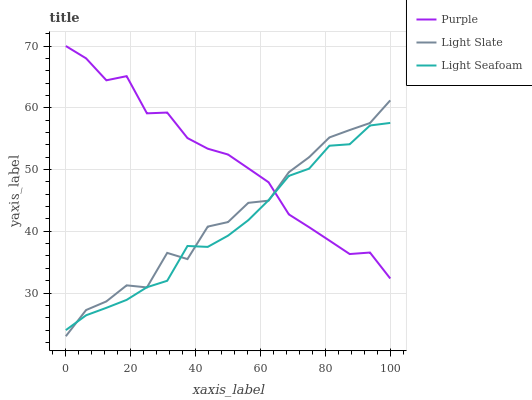Does Light Seafoam have the minimum area under the curve?
Answer yes or no. Yes. Does Purple have the maximum area under the curve?
Answer yes or no. Yes. Does Light Slate have the minimum area under the curve?
Answer yes or no. No. Does Light Slate have the maximum area under the curve?
Answer yes or no. No. Is Light Seafoam the smoothest?
Answer yes or no. Yes. Is Light Slate the roughest?
Answer yes or no. Yes. Is Light Slate the smoothest?
Answer yes or no. No. Is Light Seafoam the roughest?
Answer yes or no. No. Does Light Slate have the lowest value?
Answer yes or no. Yes. Does Light Seafoam have the lowest value?
Answer yes or no. No. Does Purple have the highest value?
Answer yes or no. Yes. Does Light Slate have the highest value?
Answer yes or no. No. Does Light Seafoam intersect Purple?
Answer yes or no. Yes. Is Light Seafoam less than Purple?
Answer yes or no. No. Is Light Seafoam greater than Purple?
Answer yes or no. No. 